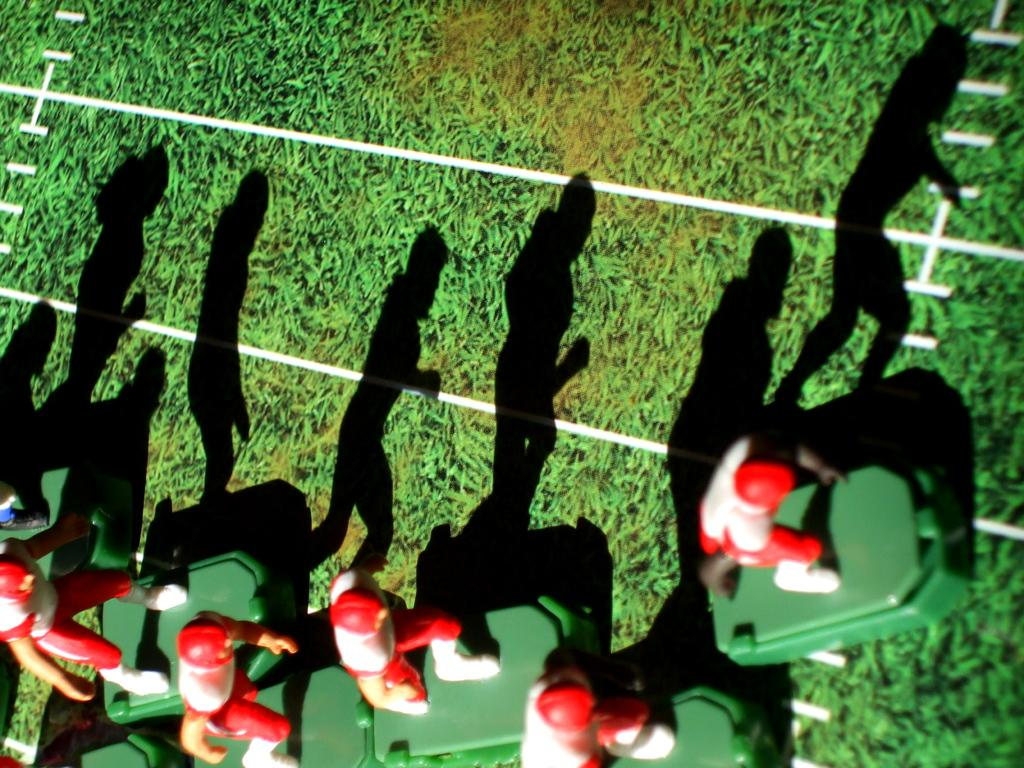What colors are the toys in the image? The toys in the image have red and white colors. What is the color of the surface on which the toys are placed? The toys are on a green surface. What type of iron can be seen in the image? There is no iron present in the image. What time of day is depicted in the image? The time of day is not mentioned or depicted in the image. 